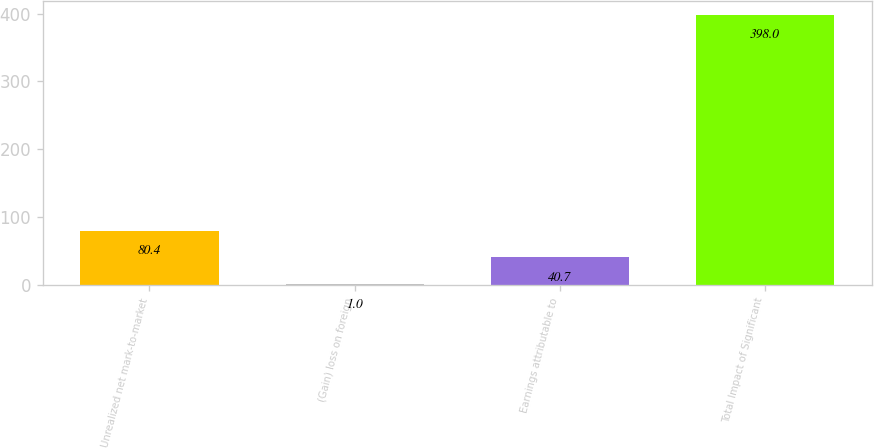Convert chart to OTSL. <chart><loc_0><loc_0><loc_500><loc_500><bar_chart><fcel>Unrealized net mark-to-market<fcel>(Gain) loss on foreign<fcel>Earnings attributable to<fcel>Total Impact of Significant<nl><fcel>80.4<fcel>1<fcel>40.7<fcel>398<nl></chart> 